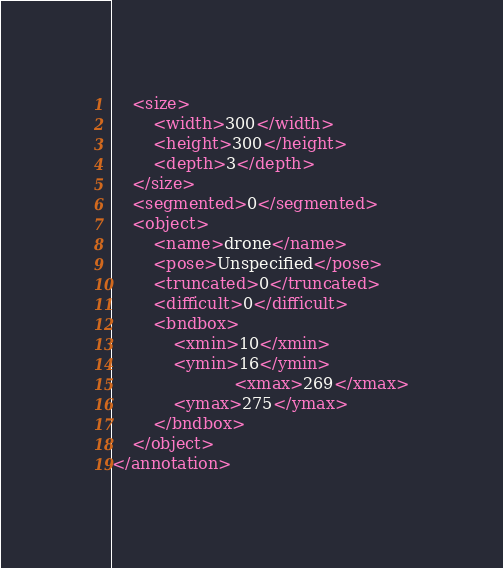<code> <loc_0><loc_0><loc_500><loc_500><_XML_>	<size>
		<width>300</width>
		<height>300</height>
		<depth>3</depth>
	</size>
	<segmented>0</segmented>
	<object>
		<name>drone</name>
		<pose>Unspecified</pose>
		<truncated>0</truncated>
		<difficult>0</difficult>
		<bndbox>
			<xmin>10</xmin>
			<ymin>16</ymin>
                        <xmax>269</xmax>
			<ymax>275</ymax>
		</bndbox>
	</object>
</annotation>
</code> 